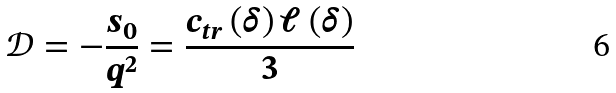<formula> <loc_0><loc_0><loc_500><loc_500>\mathcal { D } = - \frac { s _ { 0 } } { q ^ { 2 } } = \frac { c _ { t r } \left ( \delta \right ) \ell \left ( \delta \right ) } { 3 }</formula> 